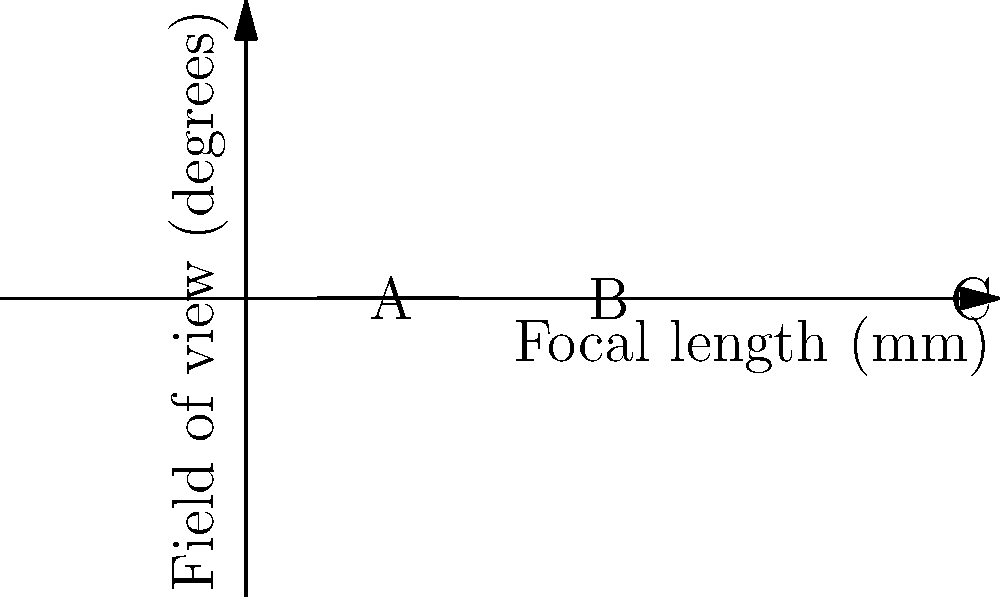The graph shows the relationship between focal length and field of view for surveillance camera lenses. Which point on the graph represents the lens with the widest coverage area for monitoring prison corridors, and how does this choice impact the overall surveillance efficiency? To answer this question, we need to understand the relationship between focal length and field of view:

1. The graph shows an inverse relationship between focal length and field of view.
2. A shorter focal length results in a wider field of view, and vice versa.
3. Point A has the shortest focal length (about 20mm) and the widest field of view (about 50°).
4. Point B has a medium focal length (about 50mm) and a medium field of view (about 20°).
5. Point C has the longest focal length (about 100mm) and the narrowest field of view (about 10°).

For monitoring prison corridors, we want the widest coverage area possible:

6. A wider field of view allows for monitoring a larger area with fewer cameras.
7. This reduces blind spots and improves overall surveillance efficiency.
8. Fewer cameras also mean lower installation and maintenance costs.

Therefore, the lens represented by Point A would be the most suitable for efficient prison corridor surveillance.

Impact on surveillance efficiency:
9. Wider coverage reduces the number of cameras needed.
10. Fewer cameras lead to simpler management and lower costs.
11. However, wider angle lenses may slightly reduce image detail at the edges.
12. The trade-off between coverage and detail is generally favorable for corridor monitoring.
Answer: Point A; wider field of view increases surveillance efficiency by maximizing coverage area and reducing the number of cameras required. 